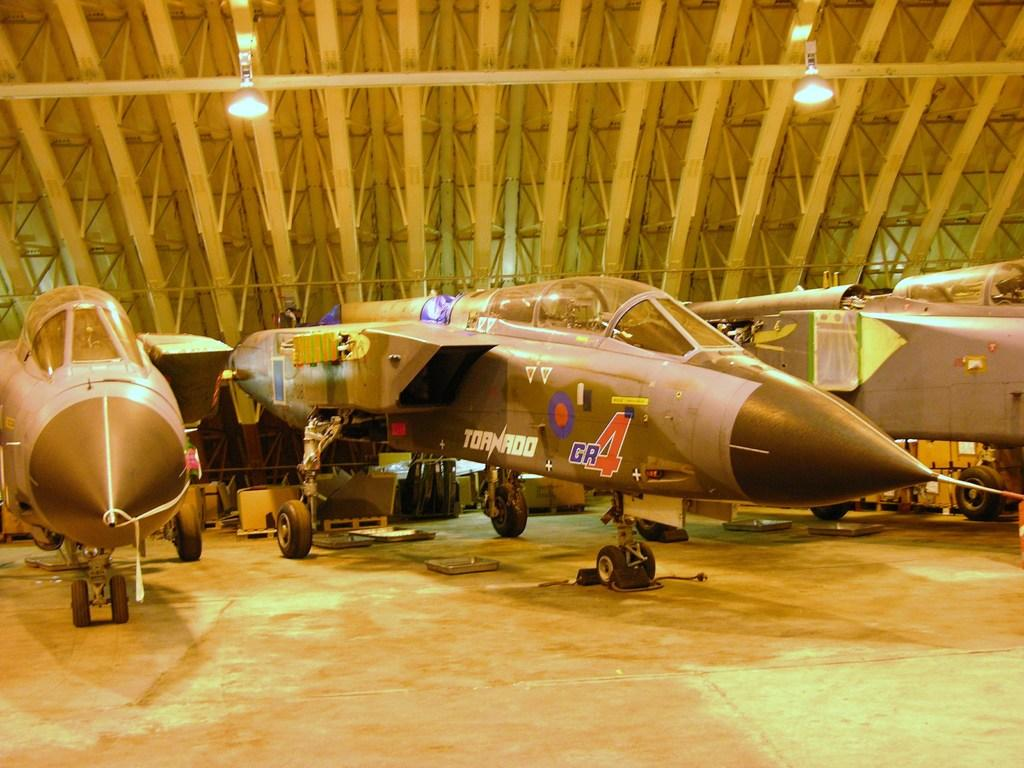<image>
Provide a brief description of the given image. may fighter jets are inside a building, one named the Tornado 